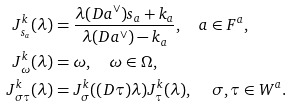<formula> <loc_0><loc_0><loc_500><loc_500>J _ { s _ { a } } ^ { k } ( \lambda ) & = \frac { \lambda ( D a ^ { \vee } ) s _ { a } + k _ { a } } { \lambda ( D a ^ { \vee } ) - k _ { a } } , \quad a \in F ^ { a } , \\ J _ { \omega } ^ { k } ( \lambda ) & = \omega , \quad \omega \in \Omega , \\ J _ { \sigma \tau } ^ { k } ( \lambda ) & = J _ { \sigma } ^ { k } ( ( D \tau ) \lambda ) J _ { \tau } ^ { k } ( \lambda ) , \quad \, \sigma , \tau \in W ^ { a } .</formula> 